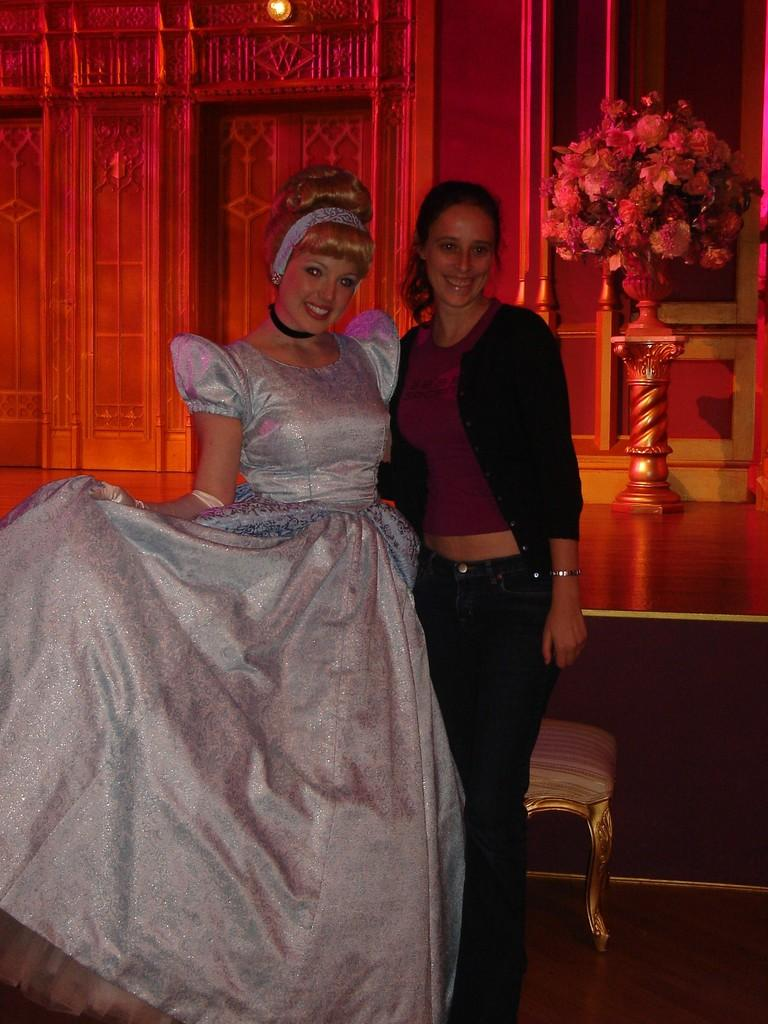How many people are in the image? There are two women standing in the image. What are the expressions on the women's faces? The women are smiling. What can be seen on the table or surface in the image? There is a flower vase with flowers in the image. What type of background is visible in the image? There appears to be a wall in the image. How many babies were born during the event depicted in the image? There is no event or babies present in the image; it features two women standing and smiling. What type of bubble is visible in the image? There is no bubble present in the image. 